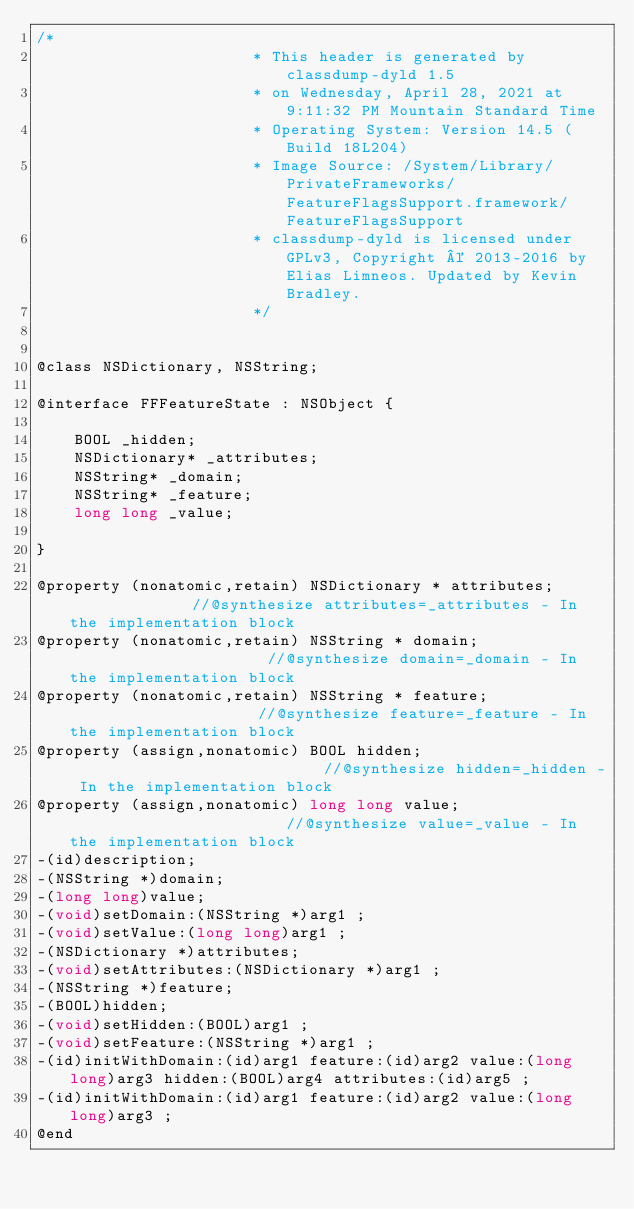<code> <loc_0><loc_0><loc_500><loc_500><_C_>/*
                       * This header is generated by classdump-dyld 1.5
                       * on Wednesday, April 28, 2021 at 9:11:32 PM Mountain Standard Time
                       * Operating System: Version 14.5 (Build 18L204)
                       * Image Source: /System/Library/PrivateFrameworks/FeatureFlagsSupport.framework/FeatureFlagsSupport
                       * classdump-dyld is licensed under GPLv3, Copyright © 2013-2016 by Elias Limneos. Updated by Kevin Bradley.
                       */


@class NSDictionary, NSString;

@interface FFFeatureState : NSObject {

	BOOL _hidden;
	NSDictionary* _attributes;
	NSString* _domain;
	NSString* _feature;
	long long _value;

}

@property (nonatomic,retain) NSDictionary * attributes;              //@synthesize attributes=_attributes - In the implementation block
@property (nonatomic,retain) NSString * domain;                      //@synthesize domain=_domain - In the implementation block
@property (nonatomic,retain) NSString * feature;                     //@synthesize feature=_feature - In the implementation block
@property (assign,nonatomic) BOOL hidden;                            //@synthesize hidden=_hidden - In the implementation block
@property (assign,nonatomic) long long value;                        //@synthesize value=_value - In the implementation block
-(id)description;
-(NSString *)domain;
-(long long)value;
-(void)setDomain:(NSString *)arg1 ;
-(void)setValue:(long long)arg1 ;
-(NSDictionary *)attributes;
-(void)setAttributes:(NSDictionary *)arg1 ;
-(NSString *)feature;
-(BOOL)hidden;
-(void)setHidden:(BOOL)arg1 ;
-(void)setFeature:(NSString *)arg1 ;
-(id)initWithDomain:(id)arg1 feature:(id)arg2 value:(long long)arg3 hidden:(BOOL)arg4 attributes:(id)arg5 ;
-(id)initWithDomain:(id)arg1 feature:(id)arg2 value:(long long)arg3 ;
@end

</code> 